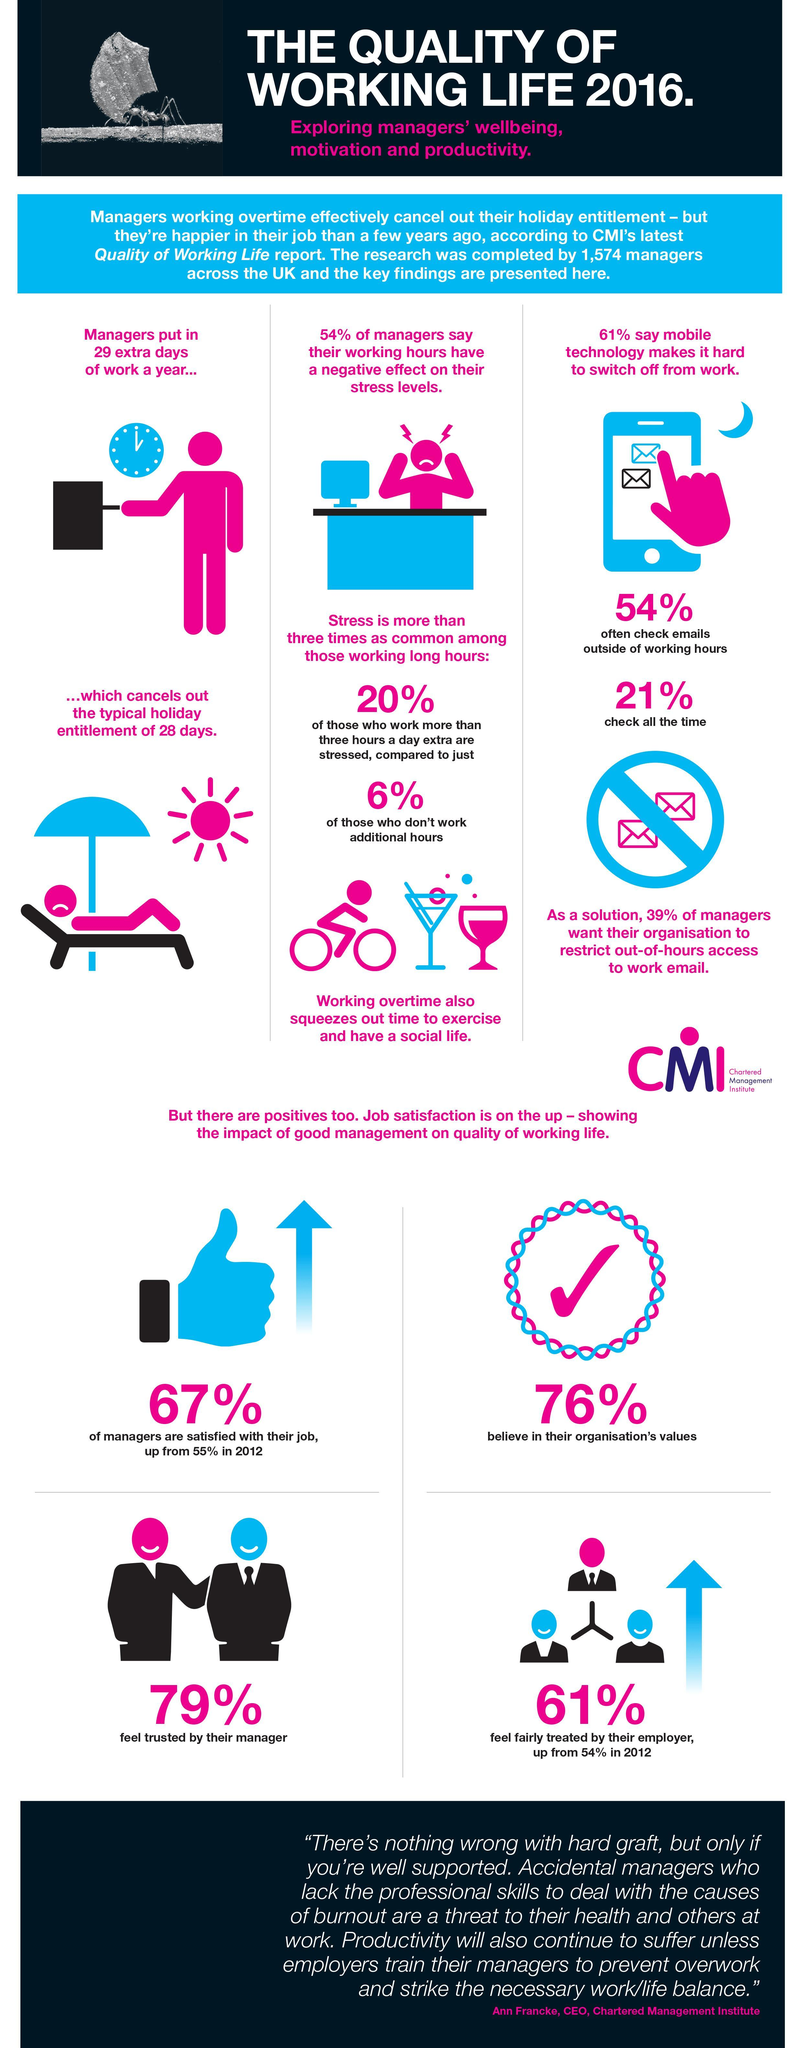What percentage of managers check their emails on their phone all the time?
Answer the question with a short phrase. 21% What percentage of managers feel that working hours impact their stress levels? 54% What perentage of managers do not believe in their organization's values? 24% What percentage feel trusted by their employer? 61% 